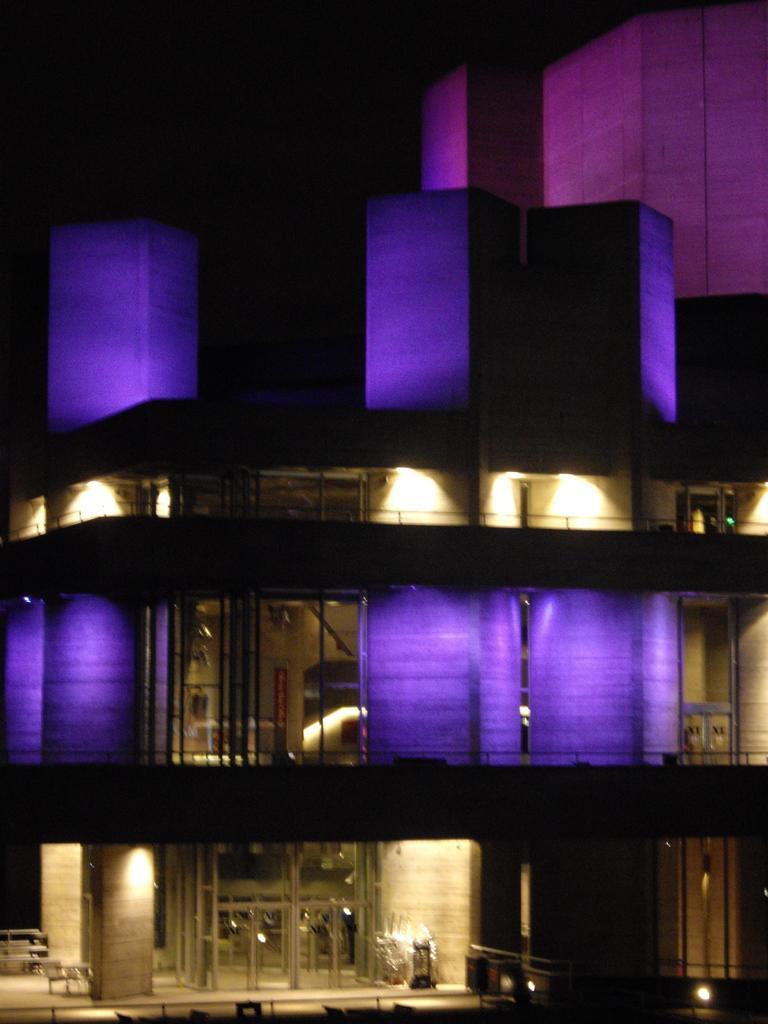In one or two sentences, can you explain what this image depicts? This is the picture of a building. In this image there is a building and there are lights inside the building. At the bottom there are tables and chairs. 